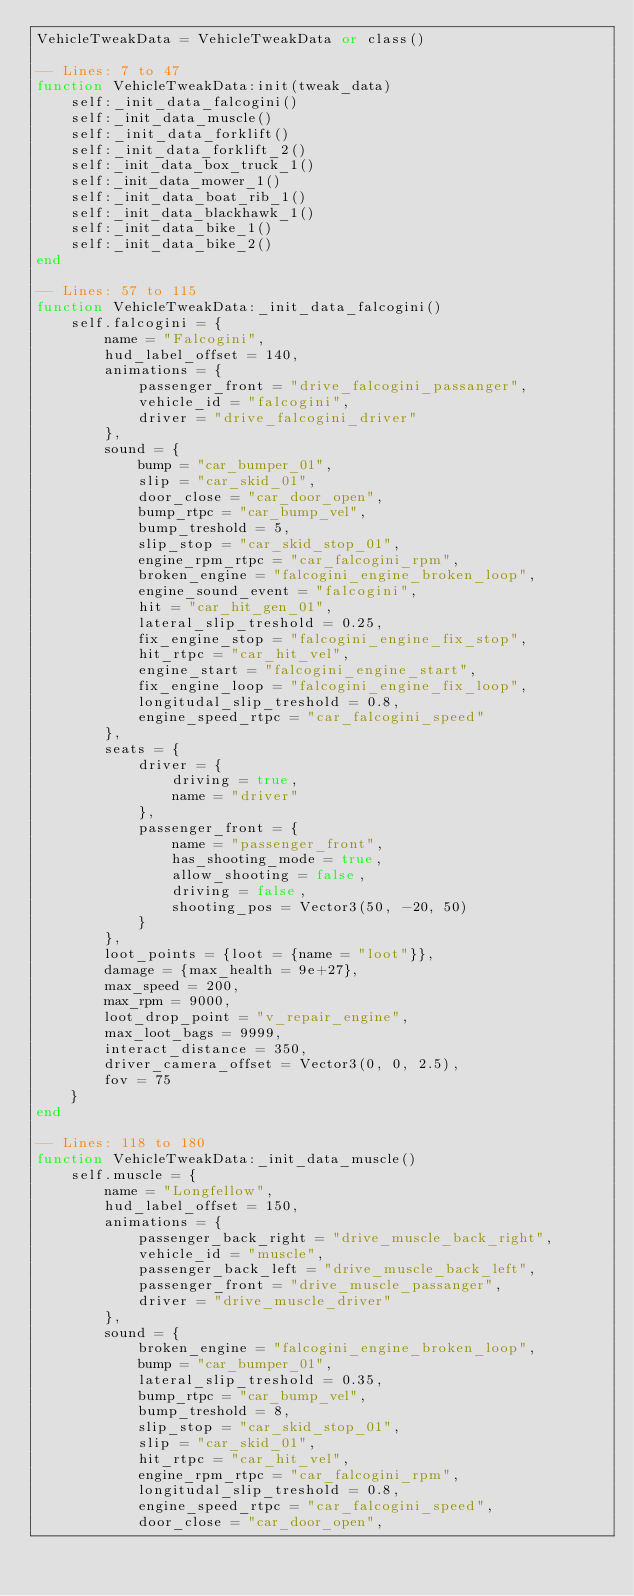<code> <loc_0><loc_0><loc_500><loc_500><_Lua_>VehicleTweakData = VehicleTweakData or class()

-- Lines: 7 to 47
function VehicleTweakData:init(tweak_data)
	self:_init_data_falcogini()
	self:_init_data_muscle()
	self:_init_data_forklift()
	self:_init_data_forklift_2()
	self:_init_data_box_truck_1()
	self:_init_data_mower_1()
	self:_init_data_boat_rib_1()
	self:_init_data_blackhawk_1()
	self:_init_data_bike_1()
	self:_init_data_bike_2()
end

-- Lines: 57 to 115
function VehicleTweakData:_init_data_falcogini()
	self.falcogini = {
		name = "Falcogini",
		hud_label_offset = 140,
		animations = {
			passenger_front = "drive_falcogini_passanger",
			vehicle_id = "falcogini",
			driver = "drive_falcogini_driver"
		},
		sound = {
			bump = "car_bumper_01",
			slip = "car_skid_01",
			door_close = "car_door_open",
			bump_rtpc = "car_bump_vel",
			bump_treshold = 5,
			slip_stop = "car_skid_stop_01",
			engine_rpm_rtpc = "car_falcogini_rpm",
			broken_engine = "falcogini_engine_broken_loop",
			engine_sound_event = "falcogini",
			hit = "car_hit_gen_01",
			lateral_slip_treshold = 0.25,
			fix_engine_stop = "falcogini_engine_fix_stop",
			hit_rtpc = "car_hit_vel",
			engine_start = "falcogini_engine_start",
			fix_engine_loop = "falcogini_engine_fix_loop",
			longitudal_slip_treshold = 0.8,
			engine_speed_rtpc = "car_falcogini_speed"
		},
		seats = {
			driver = {
				driving = true,
				name = "driver"
			},
			passenger_front = {
				name = "passenger_front",
				has_shooting_mode = true,
				allow_shooting = false,
				driving = false,
				shooting_pos = Vector3(50, -20, 50)
			}
		},
		loot_points = {loot = {name = "loot"}},
		damage = {max_health = 9e+27},
		max_speed = 200,
		max_rpm = 9000,
		loot_drop_point = "v_repair_engine",
		max_loot_bags = 9999,
		interact_distance = 350,
		driver_camera_offset = Vector3(0, 0, 2.5),
		fov = 75
	}
end

-- Lines: 118 to 180
function VehicleTweakData:_init_data_muscle()
	self.muscle = {
		name = "Longfellow",
		hud_label_offset = 150,
		animations = {
			passenger_back_right = "drive_muscle_back_right",
			vehicle_id = "muscle",
			passenger_back_left = "drive_muscle_back_left",
			passenger_front = "drive_muscle_passanger",
			driver = "drive_muscle_driver"
		},
		sound = {
			broken_engine = "falcogini_engine_broken_loop",
			bump = "car_bumper_01",
			lateral_slip_treshold = 0.35,
			bump_rtpc = "car_bump_vel",
			bump_treshold = 8,
			slip_stop = "car_skid_stop_01",
			slip = "car_skid_01",
			hit_rtpc = "car_hit_vel",
			engine_rpm_rtpc = "car_falcogini_rpm",
			longitudal_slip_treshold = 0.8,
			engine_speed_rtpc = "car_falcogini_speed",
			door_close = "car_door_open",</code> 